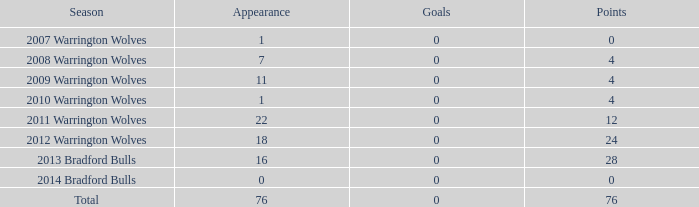When the number of goals is more than 0, what is the total appearance count? None. 